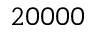Convert formula to latex. <formula><loc_0><loc_0><loc_500><loc_500>2 0 0 0 0</formula> 